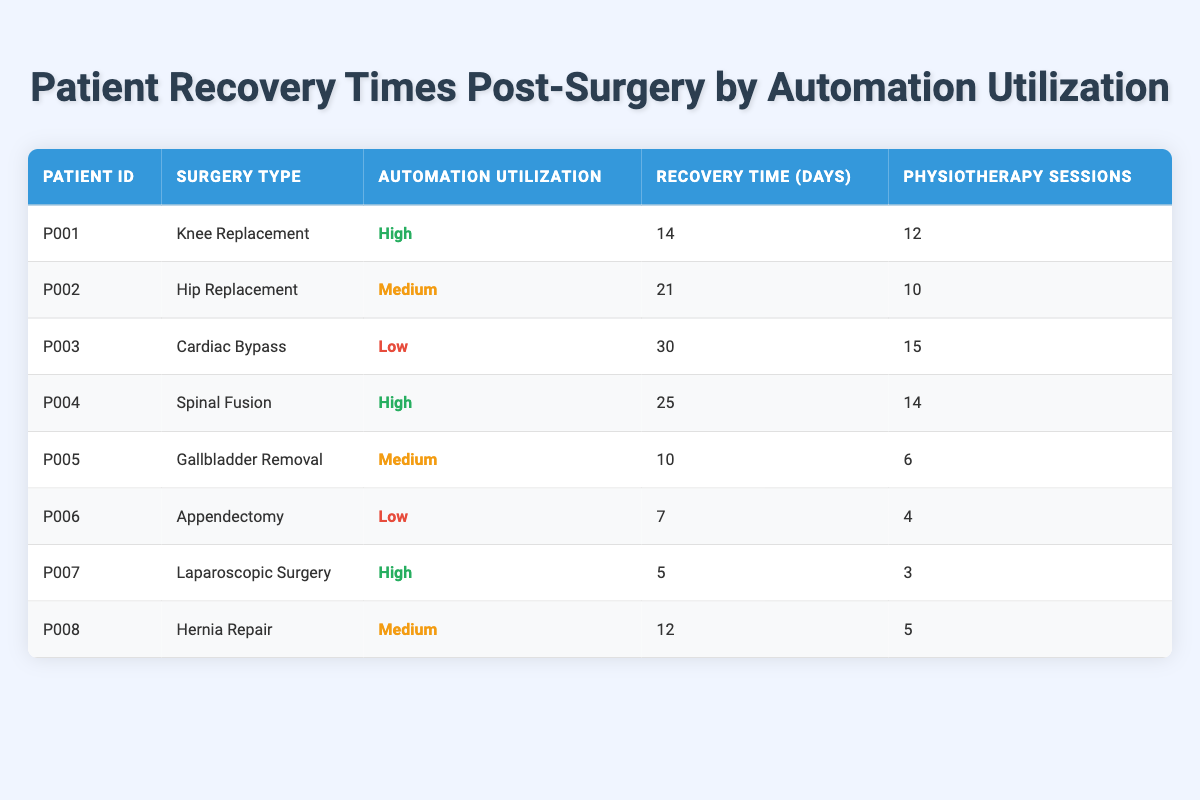What is the recovery time for Patient P001? The table indicates that Patient P001 underwent a Knee Replacement surgery and had a recovery time of 14 days.
Answer: 14 days How many physiotherapy sessions did Patient P005 attend? According to the table, Patient P005 had 6 physiotherapy sessions following Gallbladder Removal surgery.
Answer: 6 sessions Which patient had the longest recovery time and what was it? By examining the recovery times in the table, Patient P003 had the longest recovery time of 30 days after Cardiac Bypass surgery.
Answer: Patient P003, 30 days Is the recovery time for surgeries with high automation utilization generally less than for those with low automation utilization? To determine this, we can compare the recovery times: High (14, 25, 5 days), and Low (30, 7 days). The average for high is (14 + 25 + 5) / 3 = 14.67 days, and for low, it is (30 + 7) / 2 = 18.5 days. Since 14.67 is less than 18.5, the statement is true.
Answer: Yes What is the average recovery time for patients with medium automation utilization? First, identify the recovery times for medium utilization: 21 (P002), 10 (P005), and 12 (P008). The sum is 21 + 10 + 12 = 43, and there are 3 patients. The average recovery time is 43 / 3 = 14.33 days.
Answer: 14.33 days How many patients had recovery times of less than 15 days? Scanning the recovery times, the patients with less than 15 days are P005 (10), P006 (7), and P007 (5). This accounts for 3 patients.
Answer: 3 patients Did any patient utilize high automation and still have a recovery time of more than 20 days? Looking at the high automation patients: P001 (14 days), P004 (25 days), and P007 (5 days). P004 with a recovery time of 25 days did have a recovery time exceeding 20 days, so the answer is yes.
Answer: Yes What percentage of patients utilized low automation? There are 8 patients in total, with P003 and P006 having low automation utilization (2 out of 8). Therefore, the percentage is (2 / 8) * 100 = 25%.
Answer: 25% How does the average number of physiotherapy sessions compare between high and medium automation utilizations? High automation patients (P001, P004, P007) had sessions: 12, 14, and 3 (average is (12 + 14 + 3) / 3 = 9.67). Medium automation patients (P002, P005, P008) had sessions: 10, 6, and 5 (average is (10 + 6 + 5) / 3 = 7). From this, 9.67 > 7 confirms high automation typically involves more sessions.
Answer: High automation had more sessions 